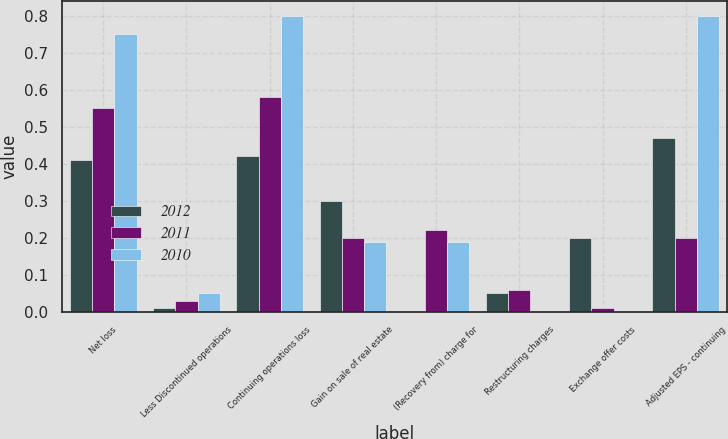Convert chart. <chart><loc_0><loc_0><loc_500><loc_500><stacked_bar_chart><ecel><fcel>Net loss<fcel>Less Discontinued operations<fcel>Continuing operations loss<fcel>Gain on sale of real estate<fcel>(Recovery from) charge for<fcel>Restructuring charges<fcel>Exchange offer costs<fcel>Adjusted EPS - continuing<nl><fcel>2012<fcel>0.41<fcel>0.01<fcel>0.42<fcel>0.3<fcel>0<fcel>0.05<fcel>0.2<fcel>0.47<nl><fcel>2011<fcel>0.55<fcel>0.03<fcel>0.58<fcel>0.2<fcel>0.22<fcel>0.06<fcel>0.01<fcel>0.2<nl><fcel>2010<fcel>0.75<fcel>0.05<fcel>0.8<fcel>0.19<fcel>0.19<fcel>0<fcel>0<fcel>0.8<nl></chart> 